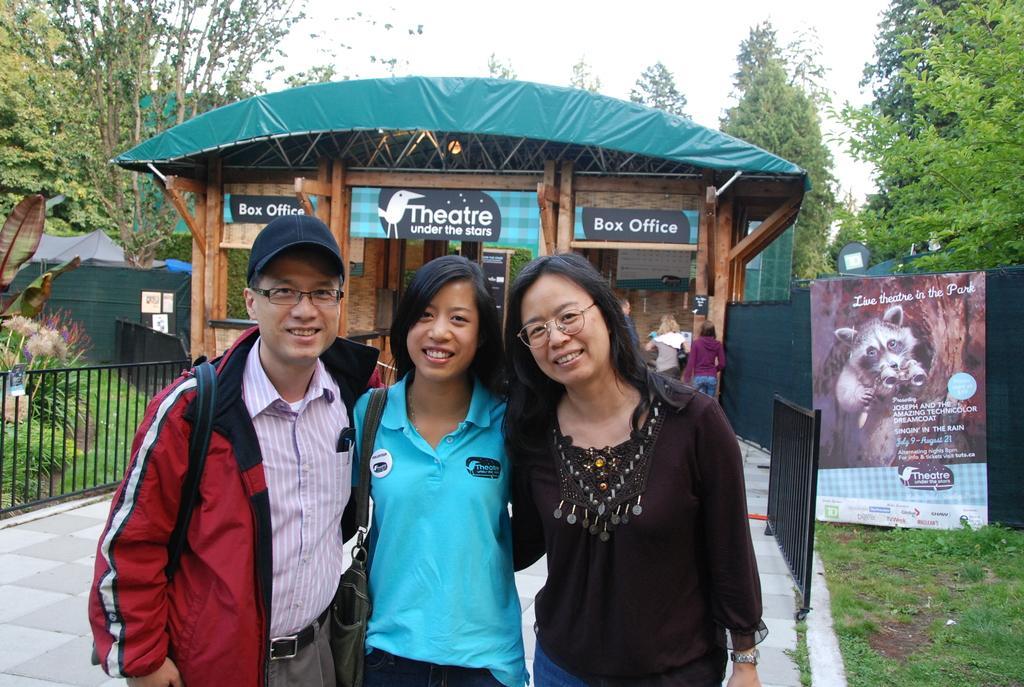In one or two sentences, can you explain what this image depicts? In this image I can see persons wearing a bag. In the background there is a shed. And beside the shed there is a poster with an image and text. And at the back there is a cloth tied to shed. And there are trees, Plants, Board, Grass and a sky. 